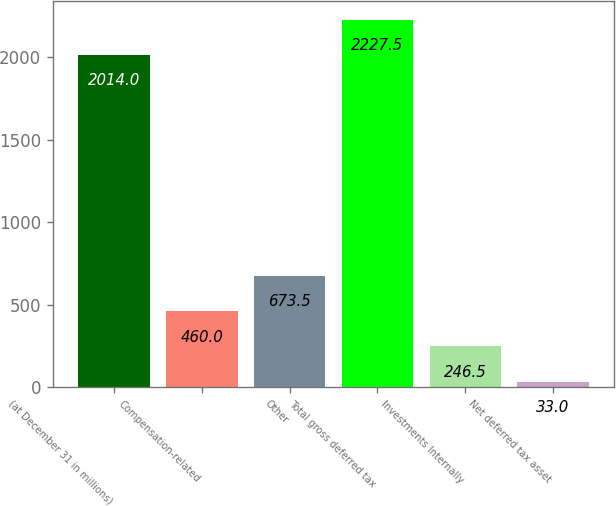<chart> <loc_0><loc_0><loc_500><loc_500><bar_chart><fcel>(at December 31 in millions)<fcel>Compensation-related<fcel>Other<fcel>Total gross deferred tax<fcel>Investments Internally<fcel>Net deferred tax asset<nl><fcel>2014<fcel>460<fcel>673.5<fcel>2227.5<fcel>246.5<fcel>33<nl></chart> 